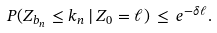Convert formula to latex. <formula><loc_0><loc_0><loc_500><loc_500>P ( Z _ { b _ { n } } \leq k _ { n } \, | \, Z _ { 0 } = \ell ) \, \leq \, e ^ { - \delta \ell } .</formula> 